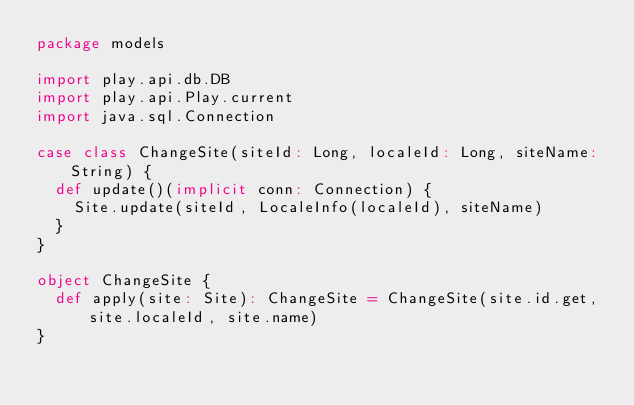<code> <loc_0><loc_0><loc_500><loc_500><_Scala_>package models

import play.api.db.DB
import play.api.Play.current
import java.sql.Connection

case class ChangeSite(siteId: Long, localeId: Long, siteName: String) {
  def update()(implicit conn: Connection) {
    Site.update(siteId, LocaleInfo(localeId), siteName)
  }
}

object ChangeSite {
  def apply(site: Site): ChangeSite = ChangeSite(site.id.get, site.localeId, site.name)
}
</code> 